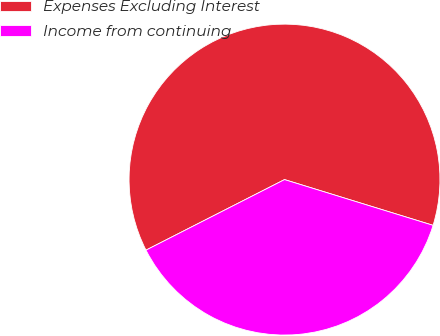Convert chart. <chart><loc_0><loc_0><loc_500><loc_500><pie_chart><fcel>Expenses Excluding Interest<fcel>Income from continuing<nl><fcel>62.25%<fcel>37.75%<nl></chart> 